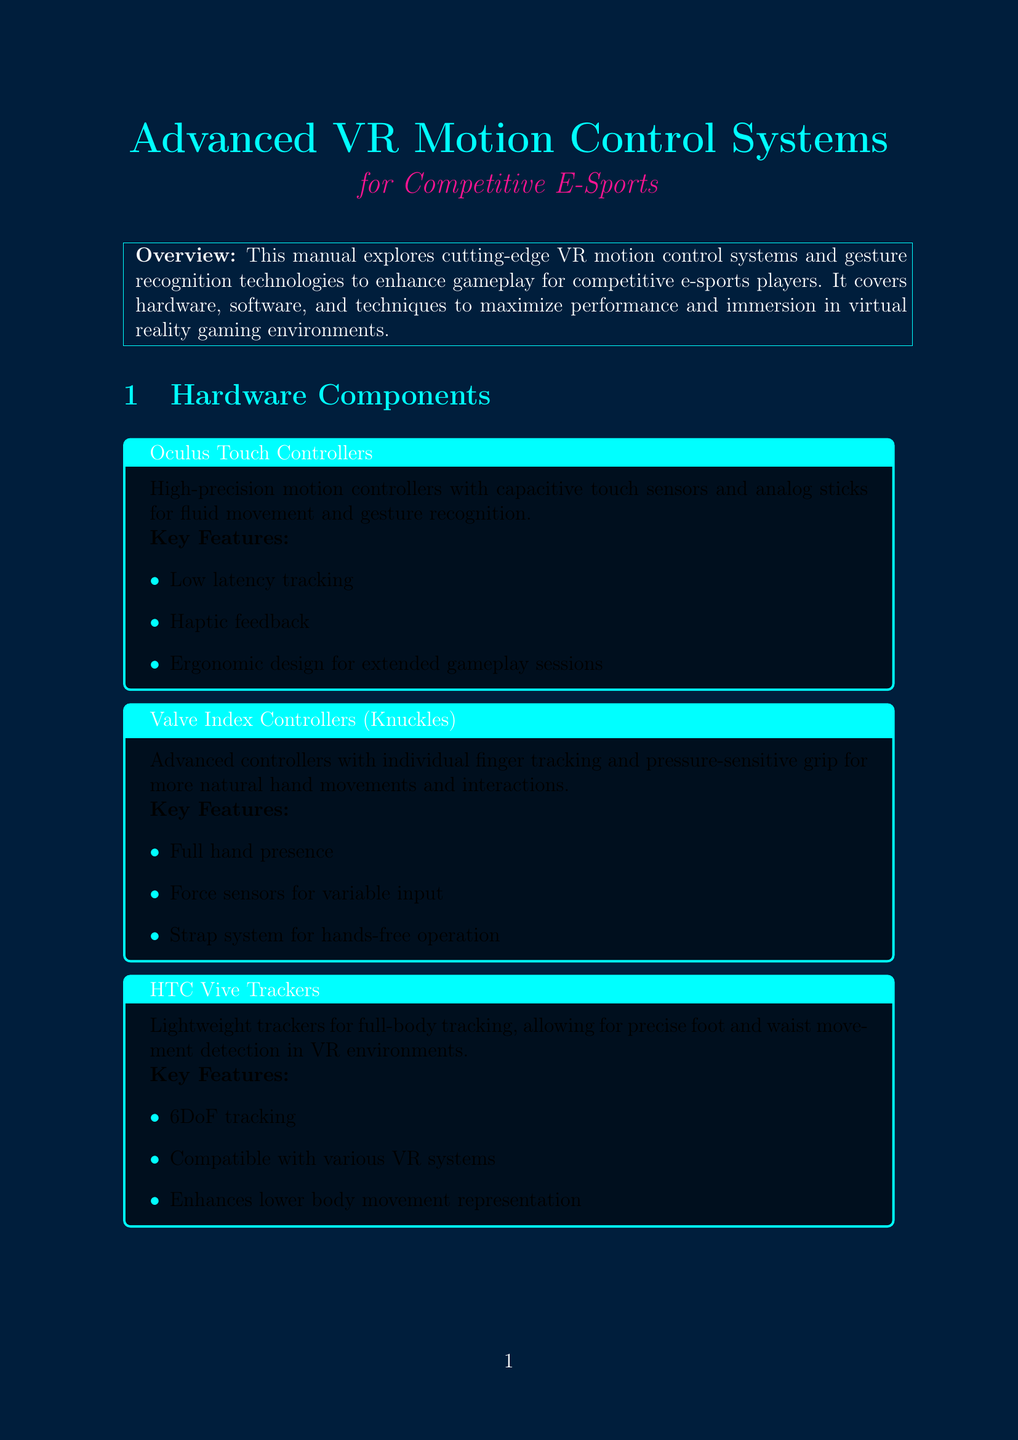What is the title of the manual? The title of the manual is presented at the beginning of the document, which is "Advanced VR Motion Control Systems for Competitive E-Sports."
Answer: Advanced VR Motion Control Systems for Competitive E-Sports What is one key feature of the Oculus Touch Controllers? One of the key features is listed among the features provided for the Oculus Touch Controllers, stating it has "Low latency tracking."
Answer: Low latency tracking Which game features realistic weapon handling with two-handed tracking? The game-specific implementation section details games and their motion control features, including indicating that "Onward" has this feature.
Answer: Onward What is a recommended app for virtual aim training? The document contains a list of recommended apps under the training exercises section, including "Aim Lab VR."
Answer: Aim Lab VR What is the main purpose of utilizing predictive motion algorithms? The reasoning behind using predictive motion algorithms is explained in the context of reducing tracking inconsistencies in competitive scenarios.
Answer: Reduce tracking inconsistencies How many advanced techniques are detailed in the document? The advanced techniques section lists three individual techniques, which can be tallied to find the total.
Answer: Three 